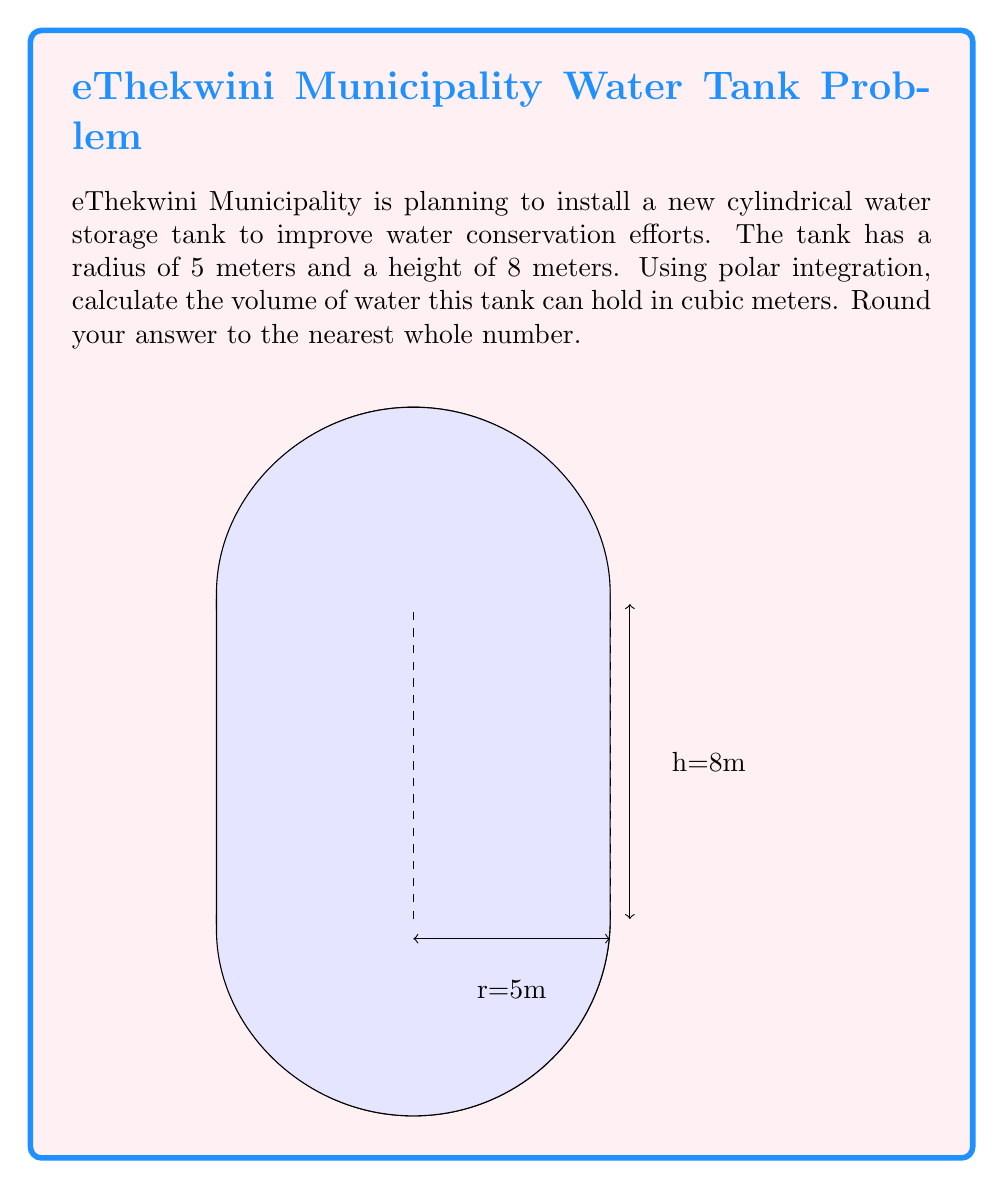Show me your answer to this math problem. To calculate the volume of a cylindrical tank using polar integration, we'll follow these steps:

1) In polar coordinates, the volume of a solid is given by the triple integral:

   $$V = \int_0^h \int_0^{2\pi} \int_0^r r \, dr \, d\theta \, dz$$

   where $h$ is the height, $r$ is the radius, and $z$ is the vertical axis.

2) Let's solve the innermost integral first:

   $$\int_0^r r \, dr = \frac{r^2}{2}\bigg|_0^r = \frac{r^2}{2}$$

3) Now our integral becomes:

   $$V = \int_0^h \int_0^{2\pi} \frac{r^2}{2} \, d\theta \, dz$$

4) Integrate with respect to $\theta$:

   $$V = \int_0^h \frac{r^2}{2} \cdot 2\pi \, dz = \pi r^2 \int_0^h \, dz$$

5) Finally, integrate with respect to $z$:

   $$V = \pi r^2 \cdot h$$

6) Now, let's substitute our values: $r = 5$ meters, $h = 8$ meters

   $$V = \pi \cdot 5^2 \cdot 8 = 200\pi \approx 628.32 \text{ cubic meters}$$

7) Rounding to the nearest whole number:

   $$V \approx 628 \text{ cubic meters}$$
Answer: 628 cubic meters 